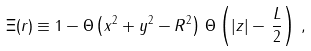Convert formula to latex. <formula><loc_0><loc_0><loc_500><loc_500>\Xi ( { r } ) \equiv 1 - \Theta \left ( x ^ { 2 } + y ^ { 2 } - R ^ { 2 } \right ) \, \Theta \left ( | z | - \, \frac { L } { 2 } \right ) \, ,</formula> 